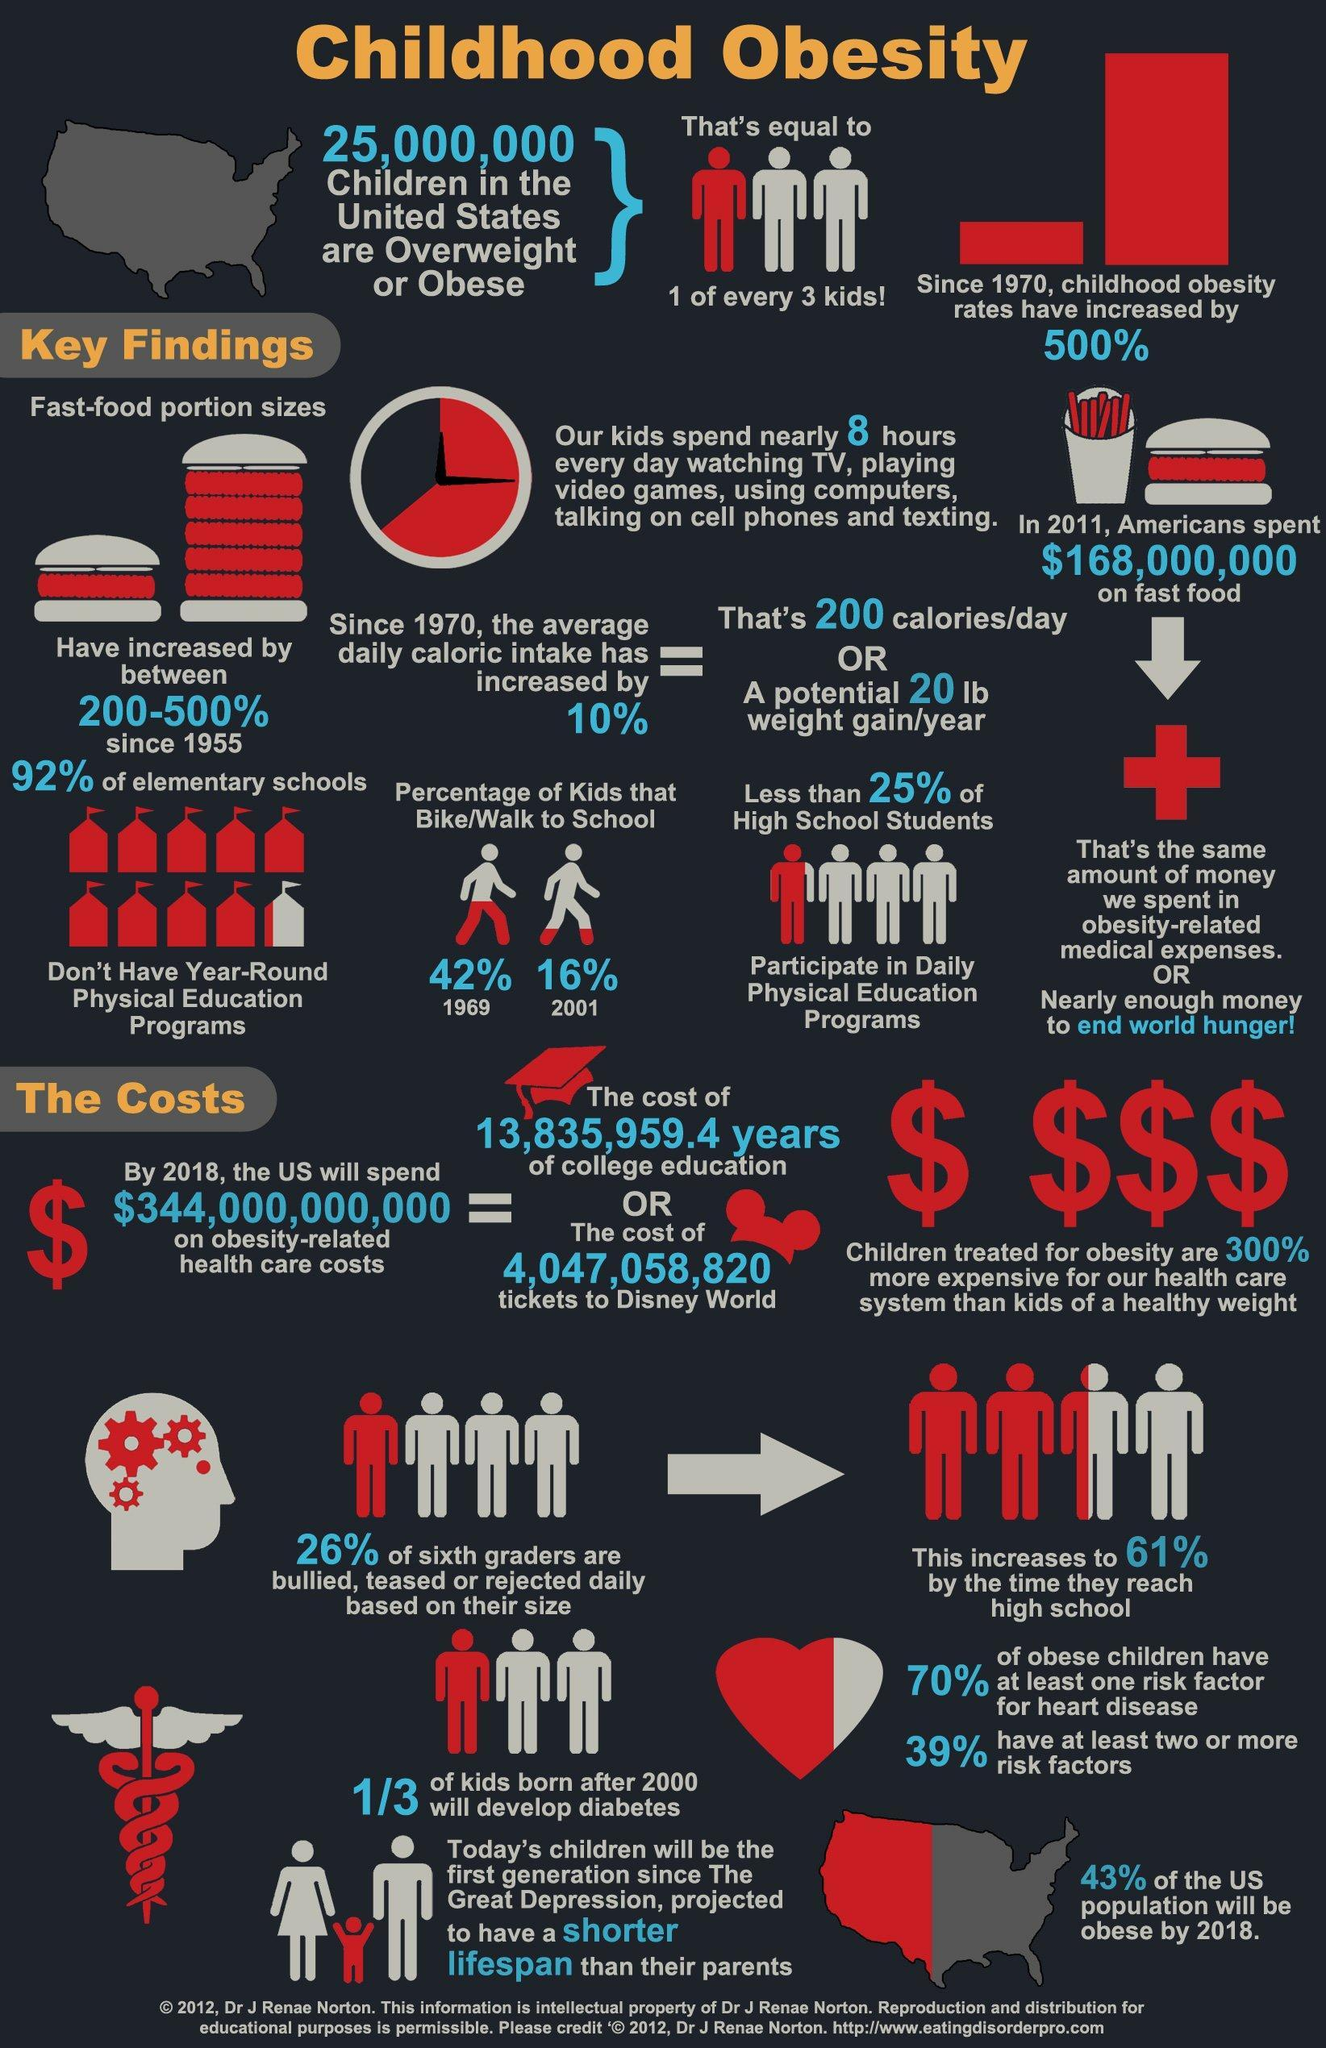By what percentage has kids walking or cycling to school reduced from 1969 to 2001?
Answer the question with a short phrase. 26% 